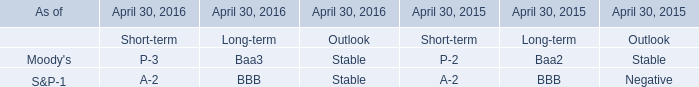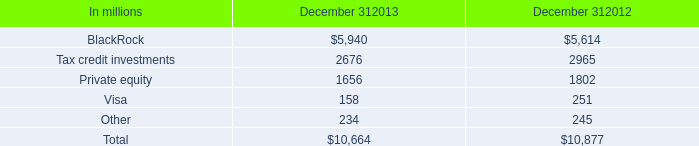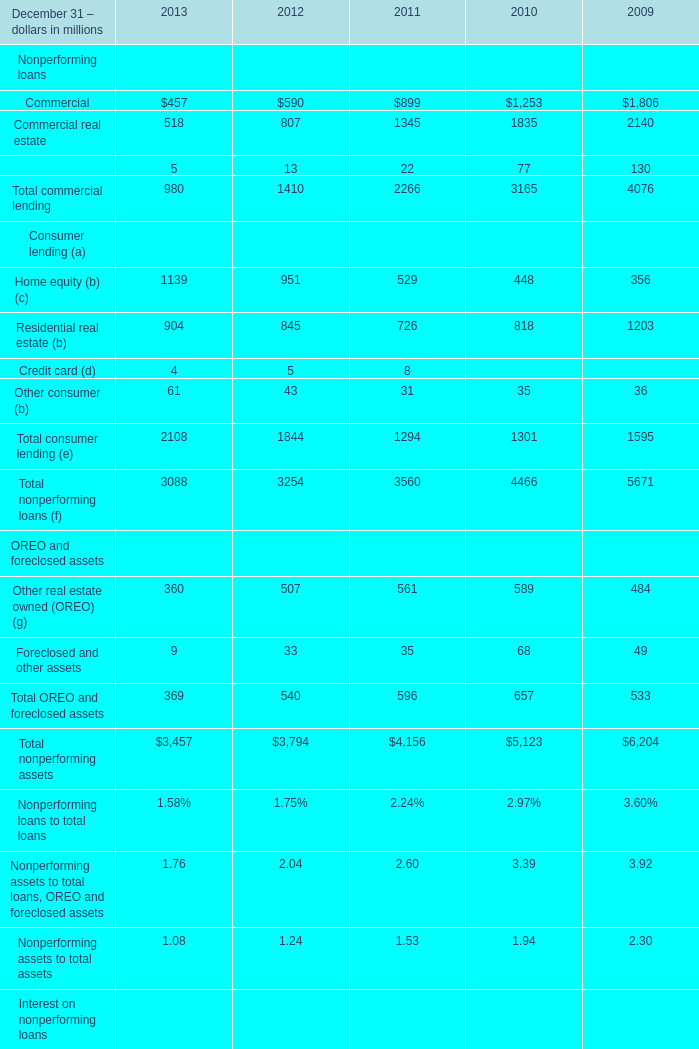What is the total amount of Commercial real estate of 2010, Private equity of December 312013, and Commercial real estate of 2011 ? 
Computations: ((1835.0 + 1656.0) + 1345.0)
Answer: 4836.0. 